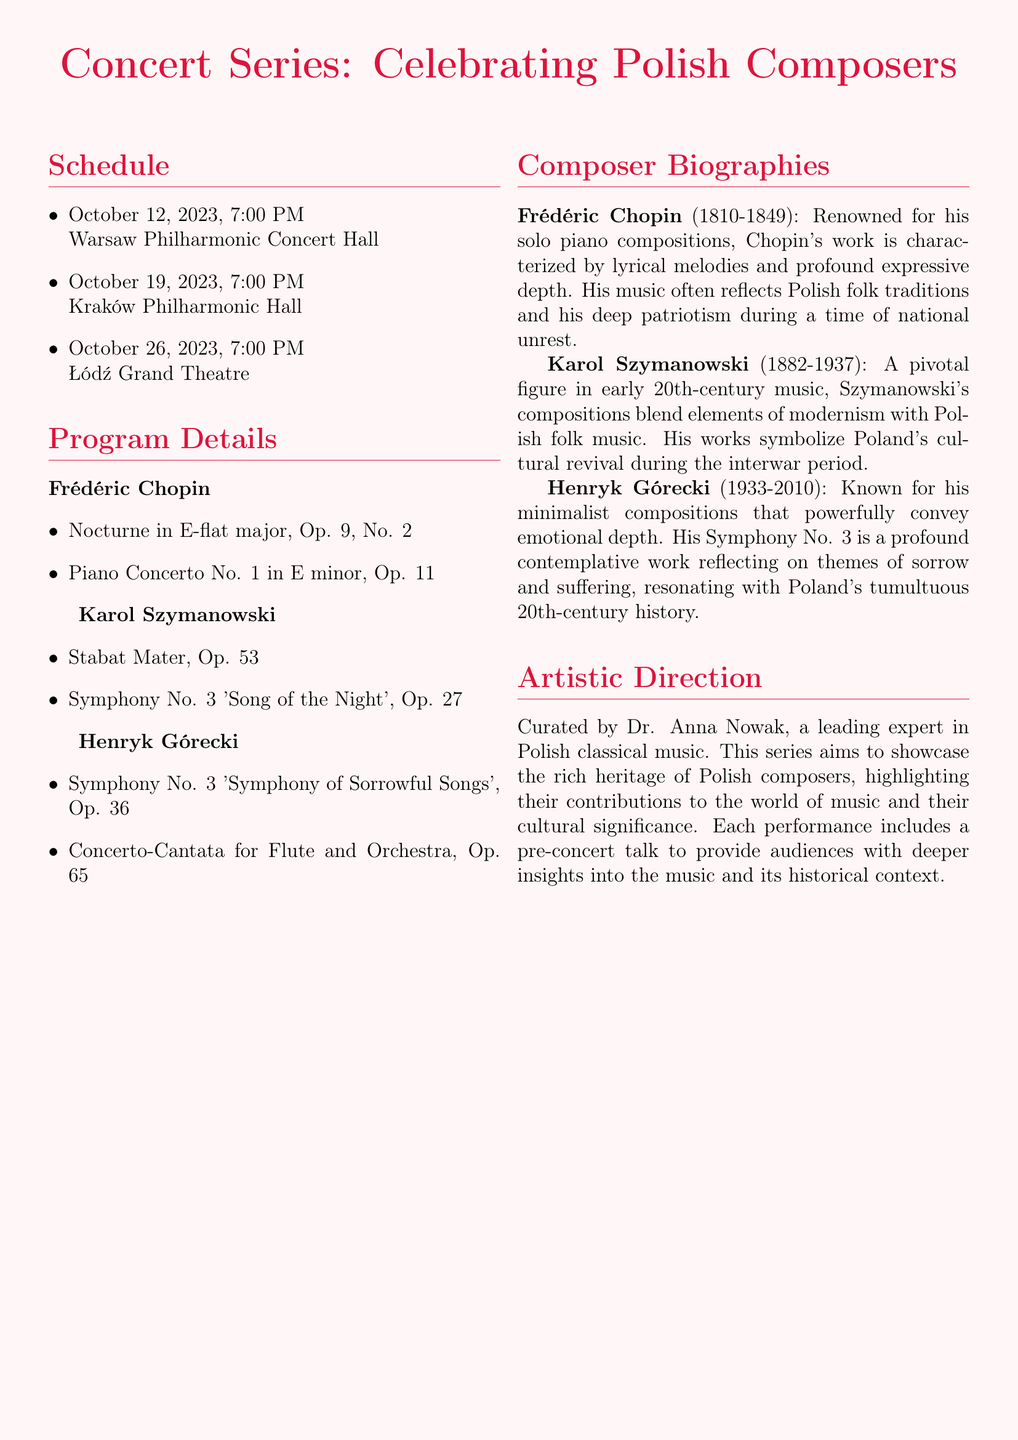What is the date of the first concert? The first concert is scheduled for October 12, 2023.
Answer: October 12, 2023 Who is the artistic director of the concert series? The artistic director of the concert series is Dr. Anna Nowak.
Answer: Dr. Anna Nowak Which composer has a piece titled "Symphony of Sorrowful Songs"? This title refers to Henryk Górecki's Symphony No. 3.
Answer: Henryk Górecki How many concerts are scheduled in the series? There are three concerts listed in the schedule.
Answer: Three What is the name of Chopin's Nocturne included in the program? The Nocturne is titled "Nocturne in E-flat major, Op. 9, No. 2".
Answer: Nocturne in E-flat major, Op. 9, No. 2 Which Hall will host the concert on October 19, 2023? The concert on this date will be held at the Kraków Philharmonic Hall.
Answer: Kraków Philharmonic Hall What is the primary focus of this concert series? The focus of the concert series is to celebrate Polish composers.
Answer: Polish composers In which century was Karol Szymanowski a pivotal figure? Karol Szymanowski was a pivotal figure in the early 20th century.
Answer: 20th century What type of music does Henryk Górecki's compositions primarily convey? Górecki's compositions convey emotional depth, often through minimalism.
Answer: Emotional depth 